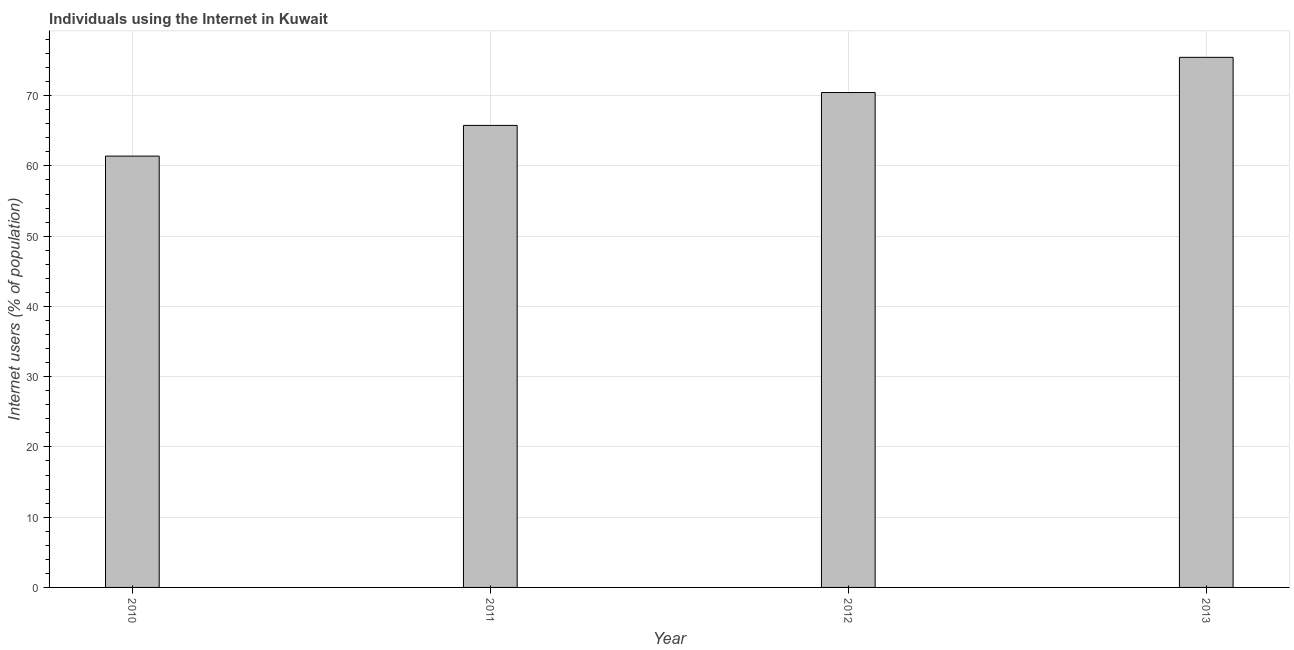Does the graph contain any zero values?
Offer a terse response. No. Does the graph contain grids?
Give a very brief answer. Yes. What is the title of the graph?
Your answer should be compact. Individuals using the Internet in Kuwait. What is the label or title of the X-axis?
Your answer should be very brief. Year. What is the label or title of the Y-axis?
Provide a succinct answer. Internet users (% of population). What is the number of internet users in 2012?
Your answer should be very brief. 70.45. Across all years, what is the maximum number of internet users?
Your answer should be very brief. 75.46. Across all years, what is the minimum number of internet users?
Give a very brief answer. 61.4. In which year was the number of internet users maximum?
Keep it short and to the point. 2013. In which year was the number of internet users minimum?
Provide a short and direct response. 2010. What is the sum of the number of internet users?
Give a very brief answer. 273.08. What is the difference between the number of internet users in 2011 and 2012?
Your answer should be compact. -4.68. What is the average number of internet users per year?
Your response must be concise. 68.27. What is the median number of internet users?
Offer a terse response. 68.11. Do a majority of the years between 2011 and 2010 (inclusive) have number of internet users greater than 2 %?
Your response must be concise. No. What is the ratio of the number of internet users in 2011 to that in 2012?
Provide a short and direct response. 0.93. Is the number of internet users in 2012 less than that in 2013?
Keep it short and to the point. Yes. Is the difference between the number of internet users in 2011 and 2013 greater than the difference between any two years?
Your response must be concise. No. What is the difference between the highest and the second highest number of internet users?
Provide a short and direct response. 5.01. What is the difference between the highest and the lowest number of internet users?
Keep it short and to the point. 14.06. In how many years, is the number of internet users greater than the average number of internet users taken over all years?
Your answer should be very brief. 2. How many bars are there?
Offer a very short reply. 4. Are all the bars in the graph horizontal?
Provide a succinct answer. No. Are the values on the major ticks of Y-axis written in scientific E-notation?
Give a very brief answer. No. What is the Internet users (% of population) of 2010?
Provide a succinct answer. 61.4. What is the Internet users (% of population) in 2011?
Your answer should be compact. 65.77. What is the Internet users (% of population) in 2012?
Keep it short and to the point. 70.45. What is the Internet users (% of population) of 2013?
Provide a short and direct response. 75.46. What is the difference between the Internet users (% of population) in 2010 and 2011?
Ensure brevity in your answer.  -4.37. What is the difference between the Internet users (% of population) in 2010 and 2012?
Your answer should be compact. -9.05. What is the difference between the Internet users (% of population) in 2010 and 2013?
Offer a terse response. -14.06. What is the difference between the Internet users (% of population) in 2011 and 2012?
Your response must be concise. -4.68. What is the difference between the Internet users (% of population) in 2011 and 2013?
Offer a terse response. -9.69. What is the difference between the Internet users (% of population) in 2012 and 2013?
Offer a terse response. -5.01. What is the ratio of the Internet users (% of population) in 2010 to that in 2011?
Give a very brief answer. 0.93. What is the ratio of the Internet users (% of population) in 2010 to that in 2012?
Provide a succinct answer. 0.87. What is the ratio of the Internet users (% of population) in 2010 to that in 2013?
Provide a succinct answer. 0.81. What is the ratio of the Internet users (% of population) in 2011 to that in 2012?
Ensure brevity in your answer.  0.93. What is the ratio of the Internet users (% of population) in 2011 to that in 2013?
Give a very brief answer. 0.87. What is the ratio of the Internet users (% of population) in 2012 to that in 2013?
Provide a short and direct response. 0.93. 